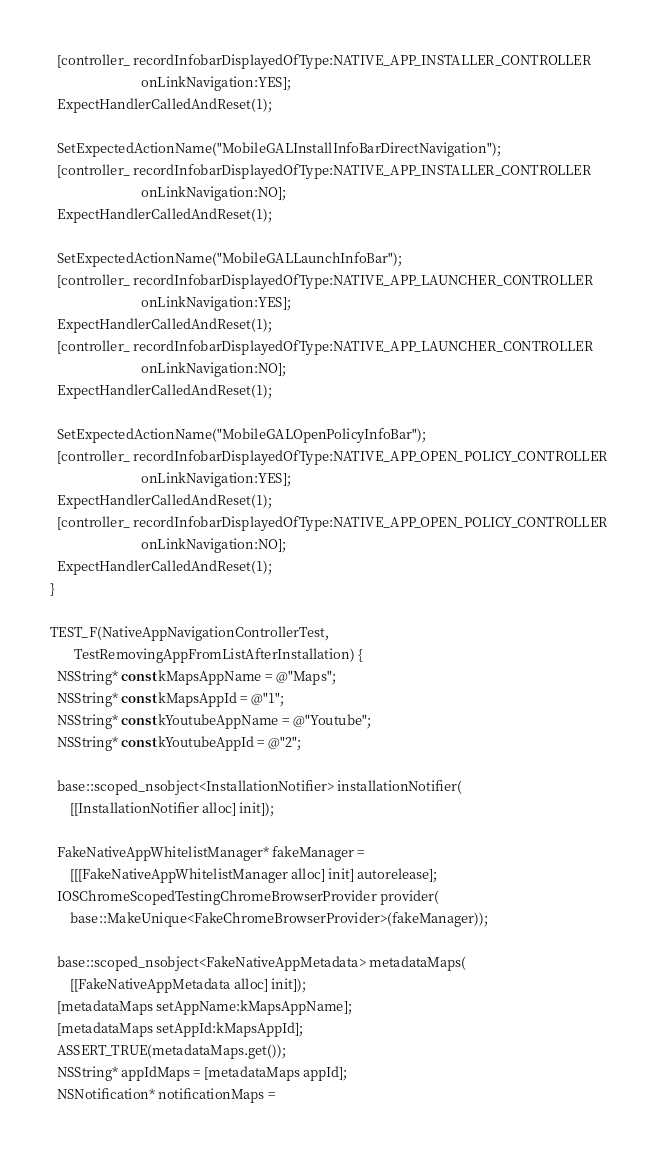Convert code to text. <code><loc_0><loc_0><loc_500><loc_500><_ObjectiveC_>  [controller_ recordInfobarDisplayedOfType:NATIVE_APP_INSTALLER_CONTROLLER
                           onLinkNavigation:YES];
  ExpectHandlerCalledAndReset(1);

  SetExpectedActionName("MobileGALInstallInfoBarDirectNavigation");
  [controller_ recordInfobarDisplayedOfType:NATIVE_APP_INSTALLER_CONTROLLER
                           onLinkNavigation:NO];
  ExpectHandlerCalledAndReset(1);

  SetExpectedActionName("MobileGALLaunchInfoBar");
  [controller_ recordInfobarDisplayedOfType:NATIVE_APP_LAUNCHER_CONTROLLER
                           onLinkNavigation:YES];
  ExpectHandlerCalledAndReset(1);
  [controller_ recordInfobarDisplayedOfType:NATIVE_APP_LAUNCHER_CONTROLLER
                           onLinkNavigation:NO];
  ExpectHandlerCalledAndReset(1);

  SetExpectedActionName("MobileGALOpenPolicyInfoBar");
  [controller_ recordInfobarDisplayedOfType:NATIVE_APP_OPEN_POLICY_CONTROLLER
                           onLinkNavigation:YES];
  ExpectHandlerCalledAndReset(1);
  [controller_ recordInfobarDisplayedOfType:NATIVE_APP_OPEN_POLICY_CONTROLLER
                           onLinkNavigation:NO];
  ExpectHandlerCalledAndReset(1);
}

TEST_F(NativeAppNavigationControllerTest,
       TestRemovingAppFromListAfterInstallation) {
  NSString* const kMapsAppName = @"Maps";
  NSString* const kMapsAppId = @"1";
  NSString* const kYoutubeAppName = @"Youtube";
  NSString* const kYoutubeAppId = @"2";

  base::scoped_nsobject<InstallationNotifier> installationNotifier(
      [[InstallationNotifier alloc] init]);

  FakeNativeAppWhitelistManager* fakeManager =
      [[[FakeNativeAppWhitelistManager alloc] init] autorelease];
  IOSChromeScopedTestingChromeBrowserProvider provider(
      base::MakeUnique<FakeChromeBrowserProvider>(fakeManager));

  base::scoped_nsobject<FakeNativeAppMetadata> metadataMaps(
      [[FakeNativeAppMetadata alloc] init]);
  [metadataMaps setAppName:kMapsAppName];
  [metadataMaps setAppId:kMapsAppId];
  ASSERT_TRUE(metadataMaps.get());
  NSString* appIdMaps = [metadataMaps appId];
  NSNotification* notificationMaps =</code> 